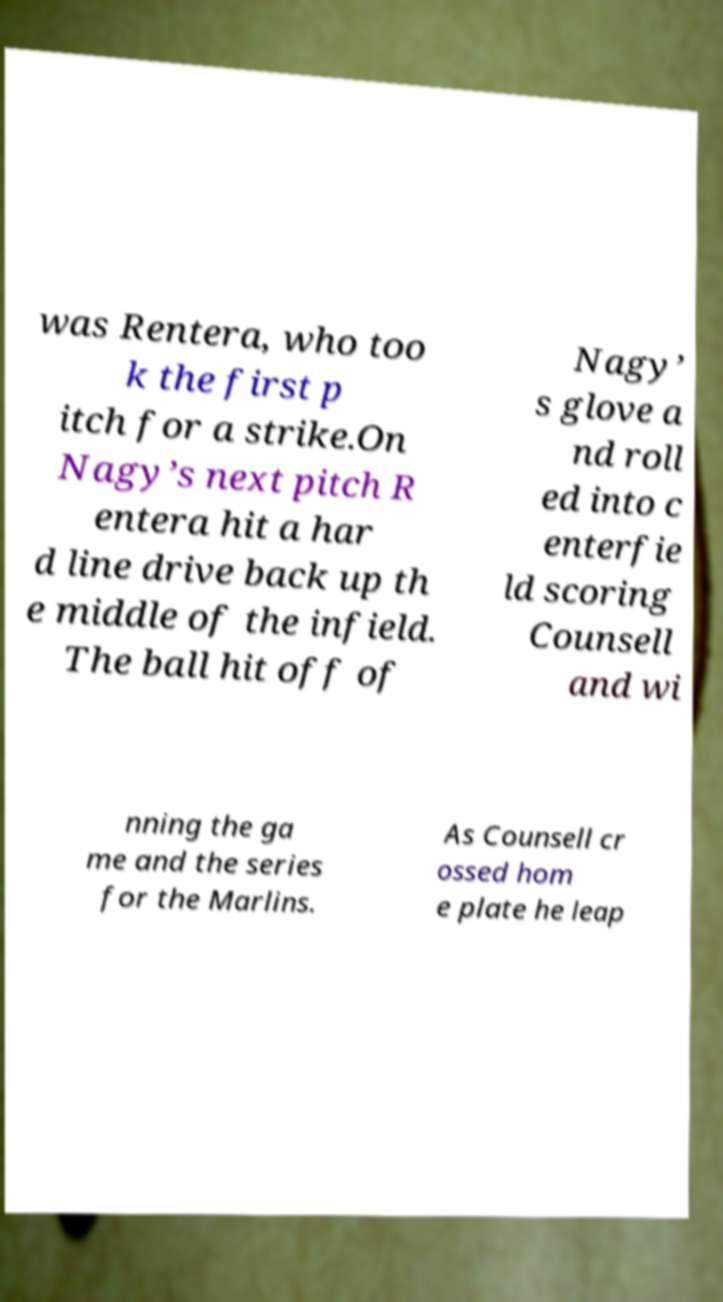Could you extract and type out the text from this image? was Rentera, who too k the first p itch for a strike.On Nagy’s next pitch R entera hit a har d line drive back up th e middle of the infield. The ball hit off of Nagy’ s glove a nd roll ed into c enterfie ld scoring Counsell and wi nning the ga me and the series for the Marlins. As Counsell cr ossed hom e plate he leap 